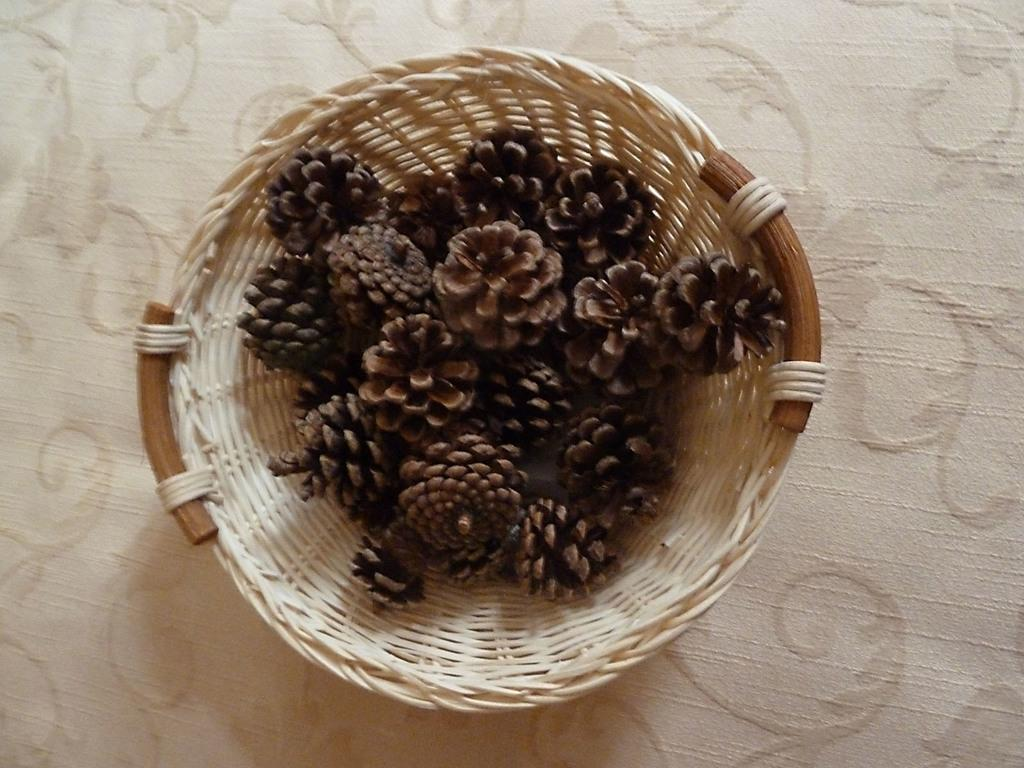What is on the table in the image? There is a basket on the table in the image. What can be found inside the basket? There are objects in the basket that resemble flowers. How many dogs are visible in the image? There are no dogs present in the image. What direction are the flowers facing in the image? The objects resembling flowers are not facing any specific direction, as they are likely artificial or decorative. 